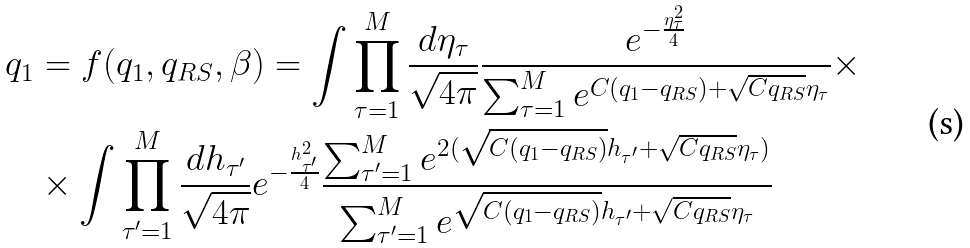<formula> <loc_0><loc_0><loc_500><loc_500>q _ { 1 } & = f ( q _ { 1 } , q _ { R S } , \beta ) = \int \prod _ { \tau = 1 } ^ { M } \frac { d \eta _ { \tau } } { \sqrt { 4 \pi } } \frac { e ^ { - \frac { \eta _ { \tau } ^ { 2 } } { 4 } } } { \sum _ { \tau = 1 } ^ { M } e ^ { C ( q _ { 1 } - q _ { R S } ) + \sqrt { C q _ { R S } } \eta _ { \tau } } } \times \\ & \times \int \prod _ { \tau ^ { \prime } = 1 } ^ { M } \frac { d h _ { \tau ^ { \prime } } } { \sqrt { 4 \pi } } e ^ { - \frac { h _ { \tau ^ { \prime } } ^ { 2 } } { 4 } } \frac { \sum _ { \tau ^ { \prime } = 1 } ^ { M } e ^ { 2 ( \sqrt { C ( q _ { 1 } - q _ { R S } ) } h _ { \tau ^ { \prime } } + \sqrt { C q _ { R S } } \eta _ { \tau } ) } } { \sum _ { \tau ^ { \prime } = 1 } ^ { M } e ^ { \sqrt { C ( q _ { 1 } - q _ { R S } ) } h _ { \tau ^ { \prime } } + \sqrt { C q _ { R S } } \eta _ { \tau } } }</formula> 